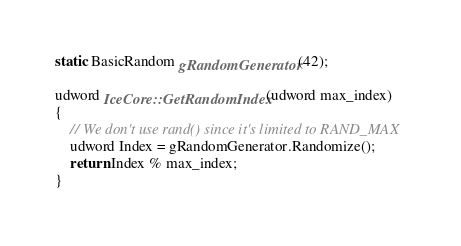Convert code to text. <code><loc_0><loc_0><loc_500><loc_500><_C++_>

static BasicRandom gRandomGenerator(42);

udword IceCore::GetRandomIndex(udword max_index)
{
	// We don't use rand() since it's limited to RAND_MAX
	udword Index = gRandomGenerator.Randomize();
	return Index % max_index;
}

</code> 